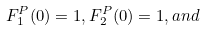<formula> <loc_0><loc_0><loc_500><loc_500>F ^ { P } _ { 1 } ( 0 ) = 1 , F ^ { P } _ { 2 } ( 0 ) = 1 , a n d</formula> 